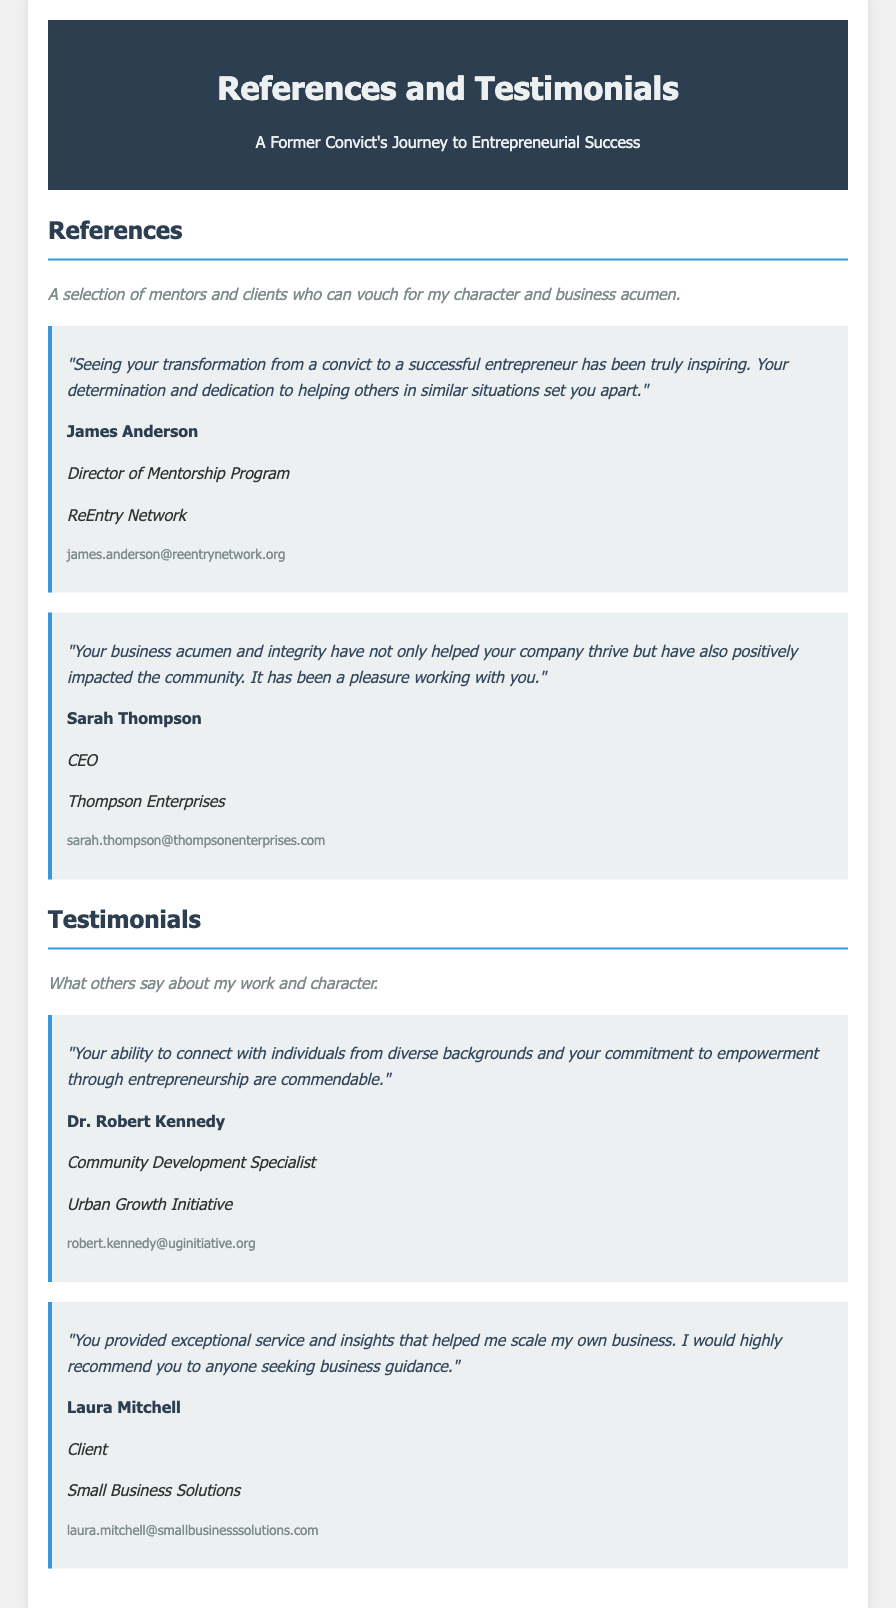What is the name of the director of the mentorship program? The director of the mentorship program is mentioned as James Anderson in the references section.
Answer: James Anderson What organization does Sarah Thompson lead? Sarah Thompson is identified as the CEO of Thompson Enterprises in the references section.
Answer: Thompson Enterprises How many testimonials are provided in the document? The document includes a total of two testimonials listed in the testimonials section.
Answer: Two Who is the first person quoted in the references section? The first reference quote is attributed to James Anderson, who speaks about transformation and inspiration.
Answer: James Anderson What is Dr. Robert Kennedy's position? Dr. Robert Kennedy is listed as a Community Development Specialist in the testimonials section.
Answer: Community Development Specialist Which organization is mentioned alongside Laura Mitchell? Laura Mitchell is associated with Small Business Solutions in the testimonials section.
Answer: Small Business Solutions 